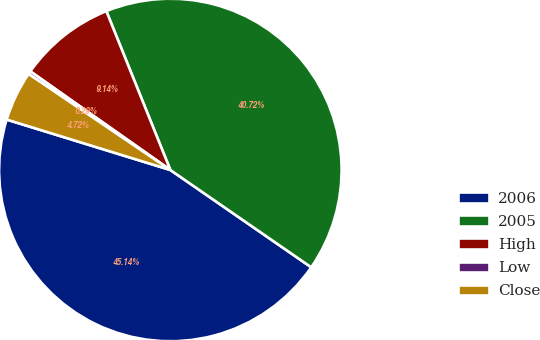<chart> <loc_0><loc_0><loc_500><loc_500><pie_chart><fcel>2006<fcel>2005<fcel>High<fcel>Low<fcel>Close<nl><fcel>45.14%<fcel>40.72%<fcel>9.14%<fcel>0.29%<fcel>4.72%<nl></chart> 